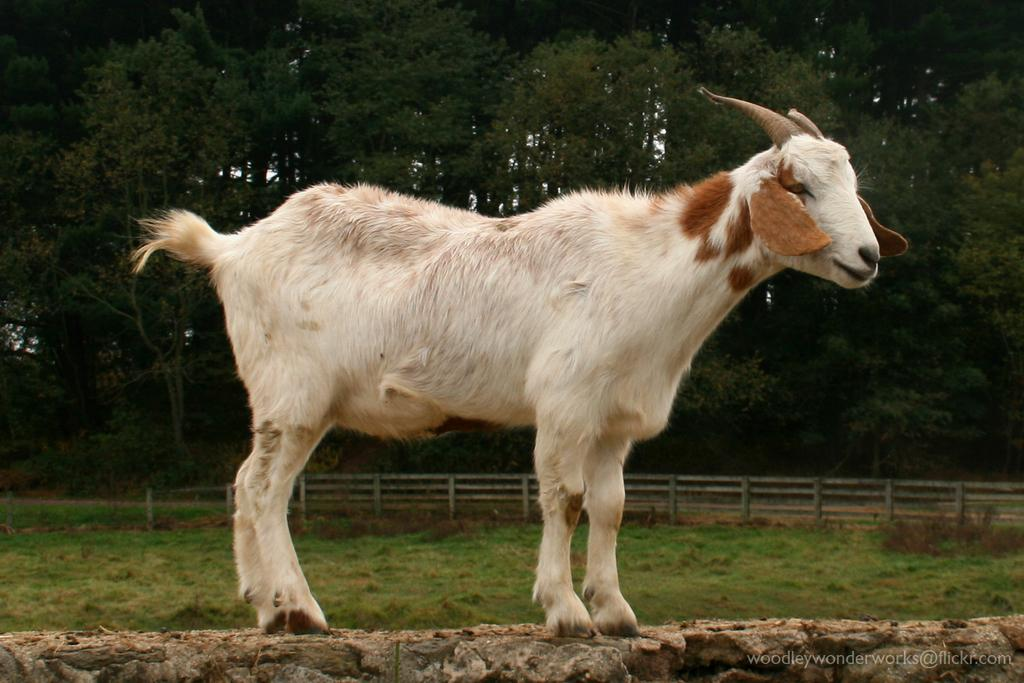What animal is in the picture? There is a goat in the picture. What is the goat standing on? The goat is standing on a log. What type of vegetation is near the goat? There is grass beside the goat. What can be seen in the background of the picture? There are trees in the picture. What type of fence is visible in the picture? There is a wooden pole fence in the picture. What type of vase is the goat holding in the picture? There is no vase present in the image; the goat is standing on a log. Can you read the note that the goat is holding in the picture? There is no note present in the image; the goat is standing on a log. 